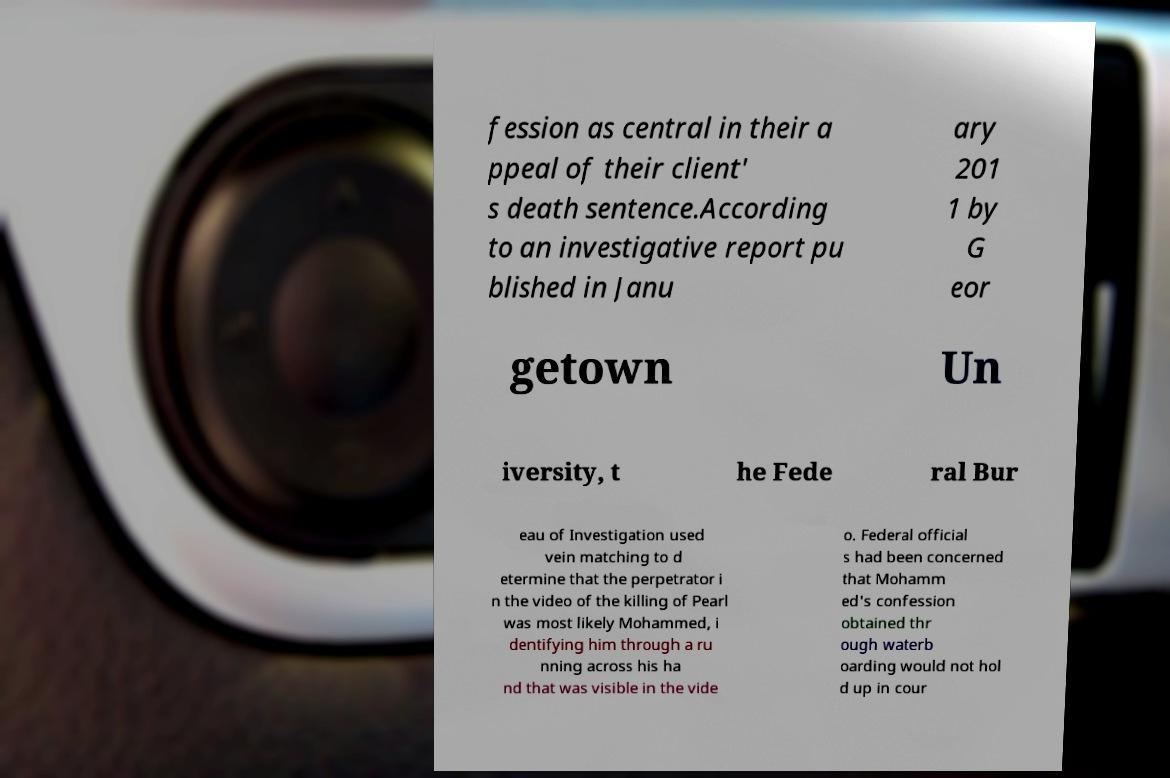I need the written content from this picture converted into text. Can you do that? fession as central in their a ppeal of their client' s death sentence.According to an investigative report pu blished in Janu ary 201 1 by G eor getown Un iversity, t he Fede ral Bur eau of Investigation used vein matching to d etermine that the perpetrator i n the video of the killing of Pearl was most likely Mohammed, i dentifying him through a ru nning across his ha nd that was visible in the vide o. Federal official s had been concerned that Mohamm ed's confession obtained thr ough waterb oarding would not hol d up in cour 